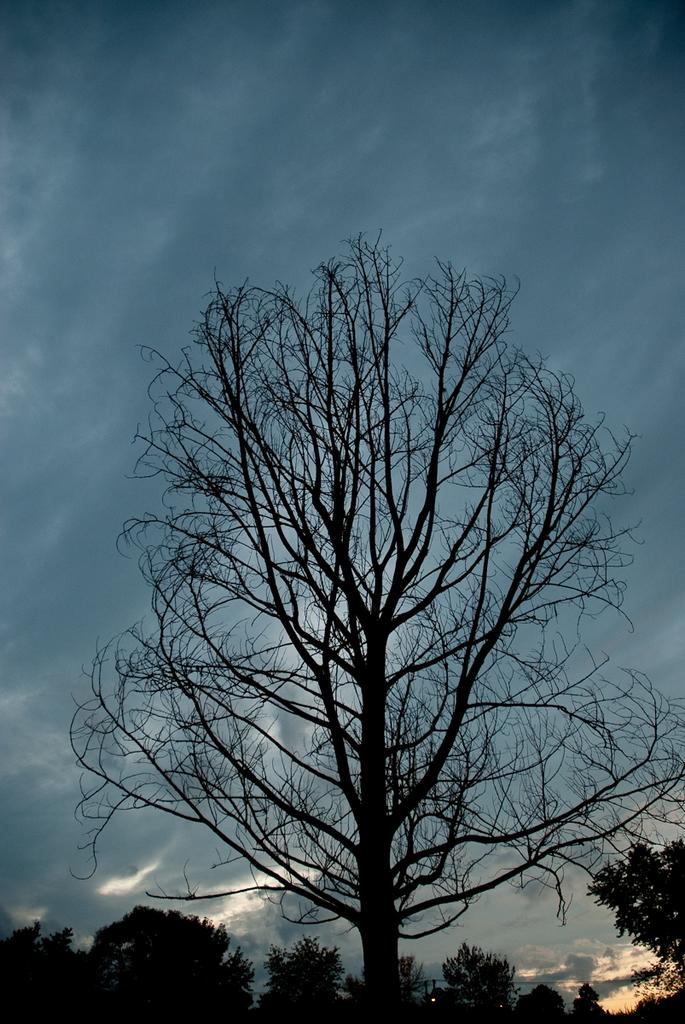What is the overall lighting condition of the image? The image is dark. What type of natural elements can be seen in the image? There are trees in the image. What is the color of the trees in the image? The trees are black in color. What can be seen in the background of the image? There is a sky visible in the background of the image. How many dogs are visible in the image? There are no dogs present in the image. Is there a plane flying in the sky in the image? There is no plane visible in the sky in the image. 